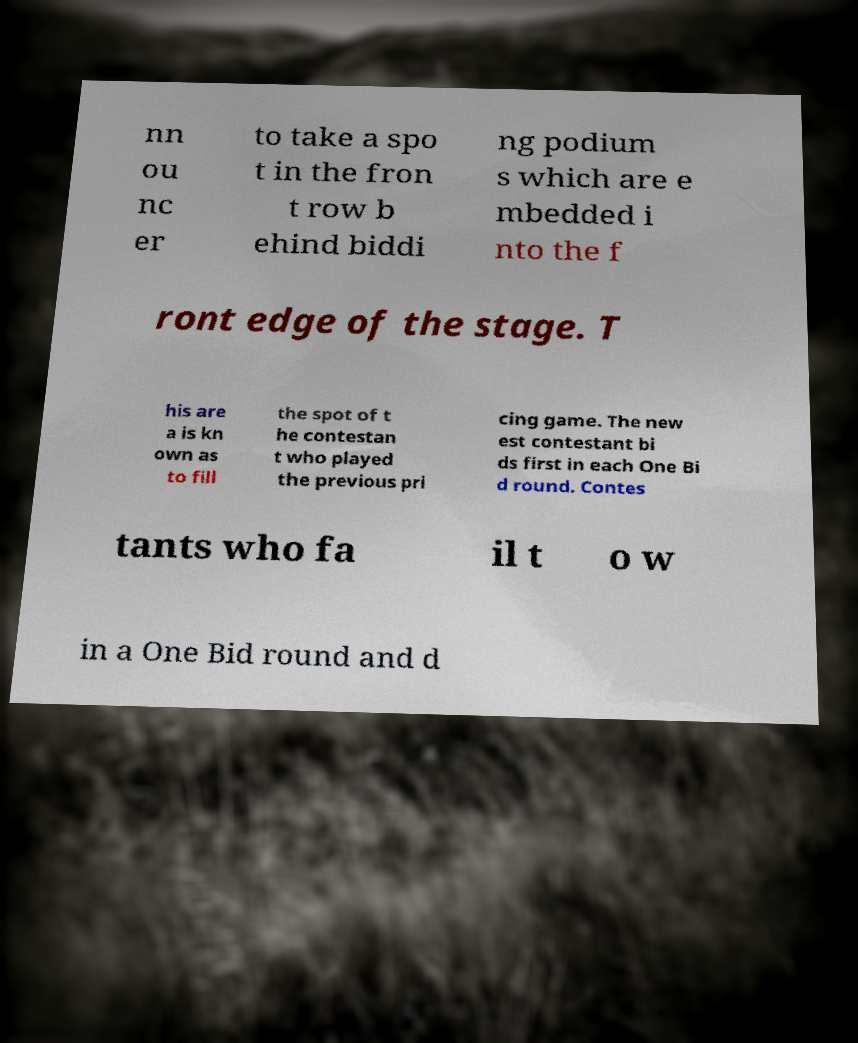I need the written content from this picture converted into text. Can you do that? nn ou nc er to take a spo t in the fron t row b ehind biddi ng podium s which are e mbedded i nto the f ront edge of the stage. T his are a is kn own as to fill the spot of t he contestan t who played the previous pri cing game. The new est contestant bi ds first in each One Bi d round. Contes tants who fa il t o w in a One Bid round and d 